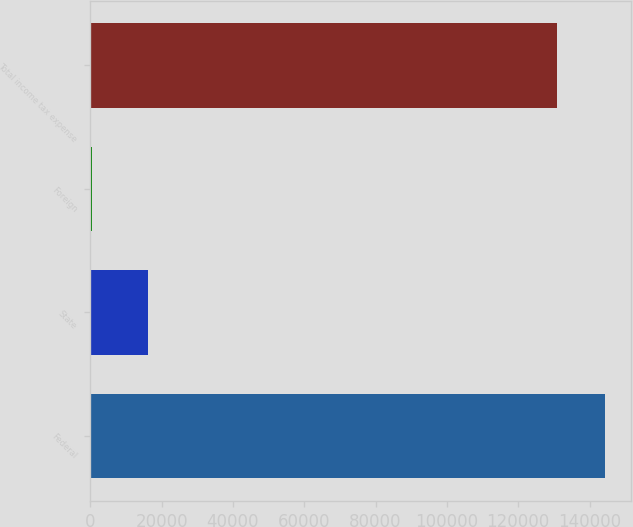Convert chart to OTSL. <chart><loc_0><loc_0><loc_500><loc_500><bar_chart><fcel>Federal<fcel>State<fcel>Foreign<fcel>Total income tax expense<nl><fcel>144300<fcel>16137<fcel>600<fcel>130888<nl></chart> 